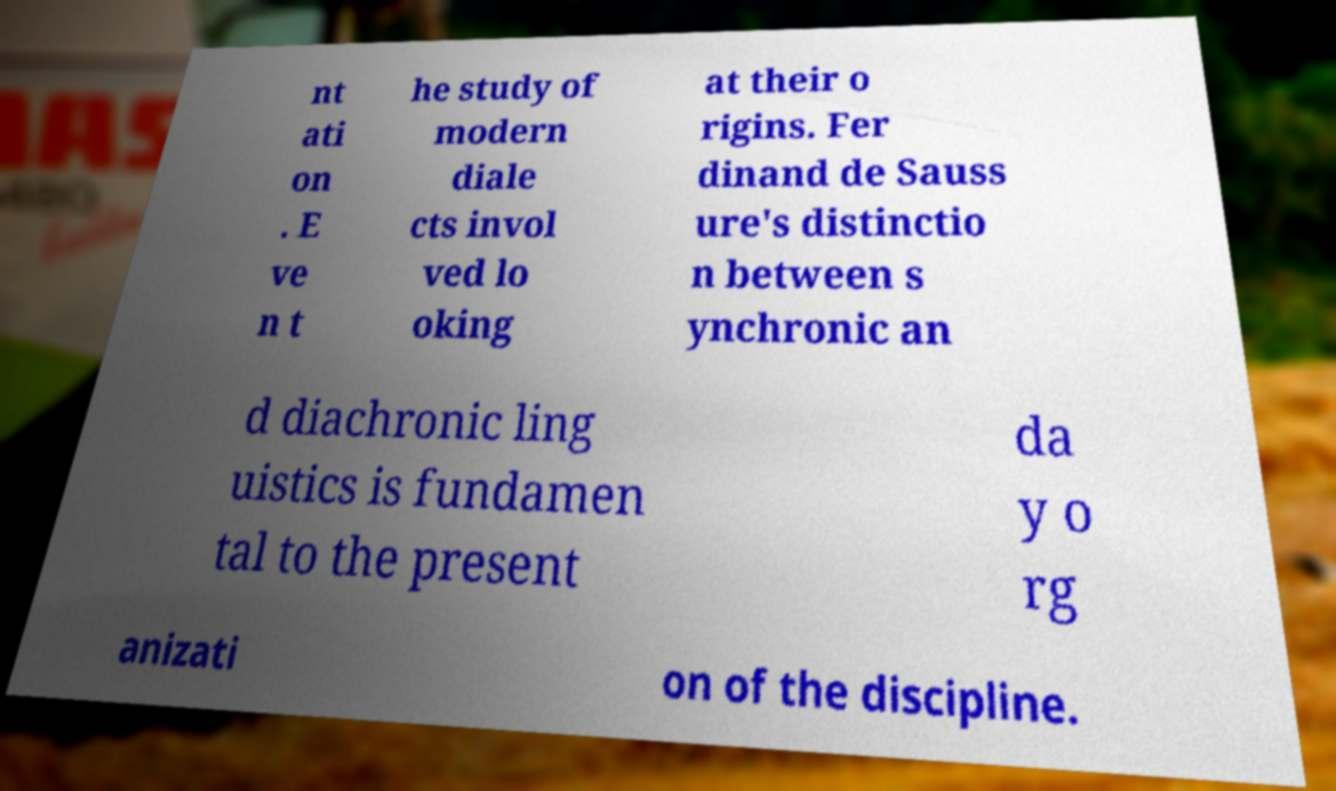I need the written content from this picture converted into text. Can you do that? nt ati on . E ve n t he study of modern diale cts invol ved lo oking at their o rigins. Fer dinand de Sauss ure's distinctio n between s ynchronic an d diachronic ling uistics is fundamen tal to the present da y o rg anizati on of the discipline. 